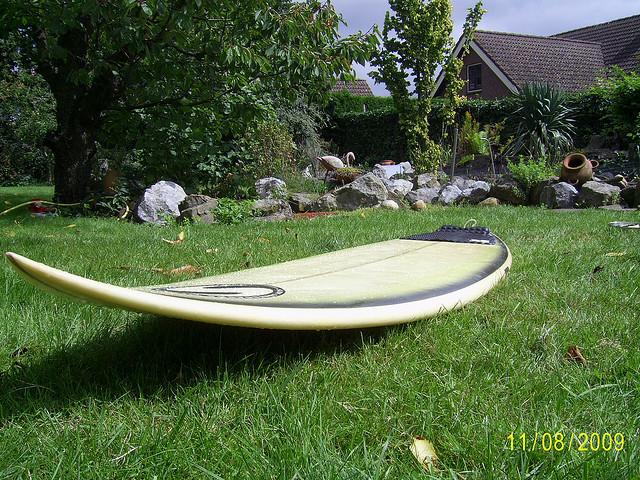How many surfboards are there?
Give a very brief answer. 1. Is this a paddleboard or a surfboard?
Answer briefly. Surfboard. What number of yellow boards are in this image?
Answer briefly. 1. Is the swan alive?
Write a very short answer. No. What is the object with the round opening on the right?
Concise answer only. Surfboard. 